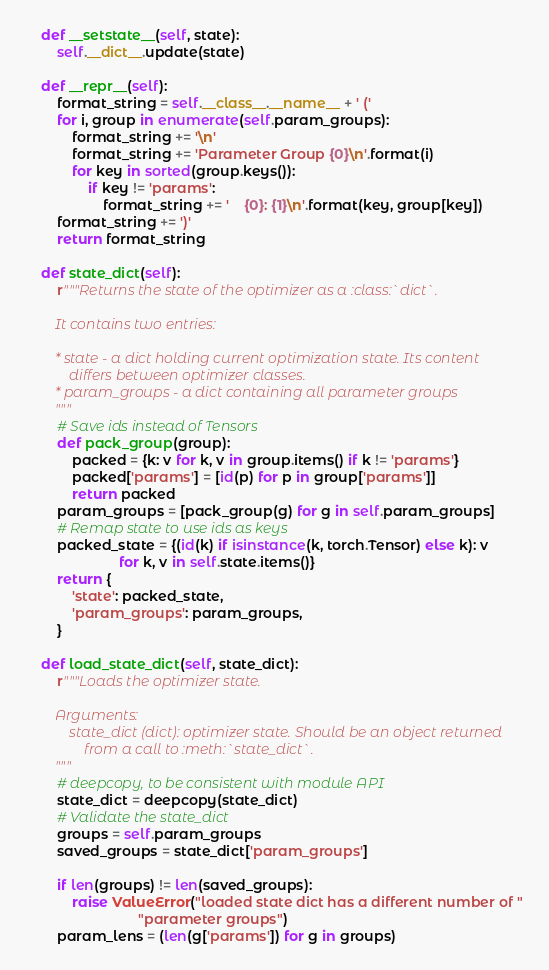Convert code to text. <code><loc_0><loc_0><loc_500><loc_500><_Python_>
    def __setstate__(self, state):
        self.__dict__.update(state)

    def __repr__(self):
        format_string = self.__class__.__name__ + ' ('
        for i, group in enumerate(self.param_groups):
            format_string += '\n'
            format_string += 'Parameter Group {0}\n'.format(i)
            for key in sorted(group.keys()):
                if key != 'params':
                    format_string += '    {0}: {1}\n'.format(key, group[key])
        format_string += ')'
        return format_string

    def state_dict(self):
        r"""Returns the state of the optimizer as a :class:`dict`.

        It contains two entries:

        * state - a dict holding current optimization state. Its content
            differs between optimizer classes.
        * param_groups - a dict containing all parameter groups
        """
        # Save ids instead of Tensors
        def pack_group(group):
            packed = {k: v for k, v in group.items() if k != 'params'}
            packed['params'] = [id(p) for p in group['params']]
            return packed
        param_groups = [pack_group(g) for g in self.param_groups]
        # Remap state to use ids as keys
        packed_state = {(id(k) if isinstance(k, torch.Tensor) else k): v
                        for k, v in self.state.items()}
        return {
            'state': packed_state,
            'param_groups': param_groups,
        }

    def load_state_dict(self, state_dict):
        r"""Loads the optimizer state.

        Arguments:
            state_dict (dict): optimizer state. Should be an object returned
                from a call to :meth:`state_dict`.
        """
        # deepcopy, to be consistent with module API
        state_dict = deepcopy(state_dict)
        # Validate the state_dict
        groups = self.param_groups
        saved_groups = state_dict['param_groups']

        if len(groups) != len(saved_groups):
            raise ValueError("loaded state dict has a different number of "
                             "parameter groups")
        param_lens = (len(g['params']) for g in groups)</code> 